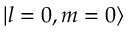<formula> <loc_0><loc_0><loc_500><loc_500>\left | l = 0 , m = 0 \right ></formula> 